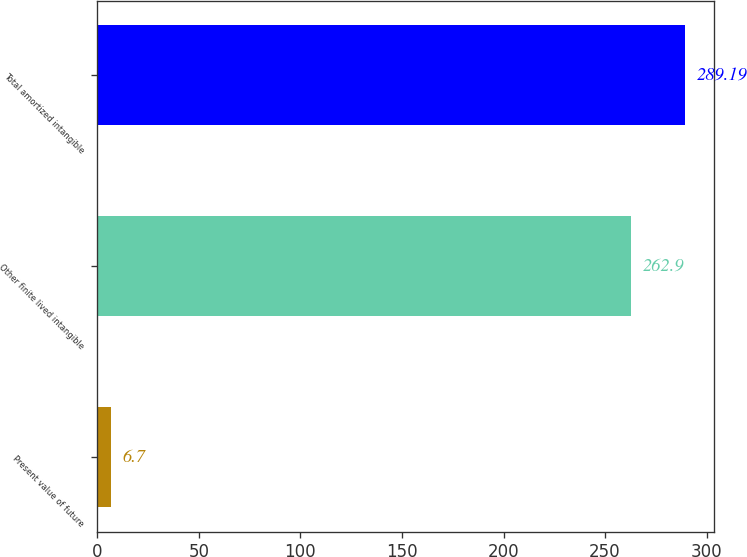<chart> <loc_0><loc_0><loc_500><loc_500><bar_chart><fcel>Present value of future<fcel>Other finite lived intangible<fcel>Total amortized intangible<nl><fcel>6.7<fcel>262.9<fcel>289.19<nl></chart> 